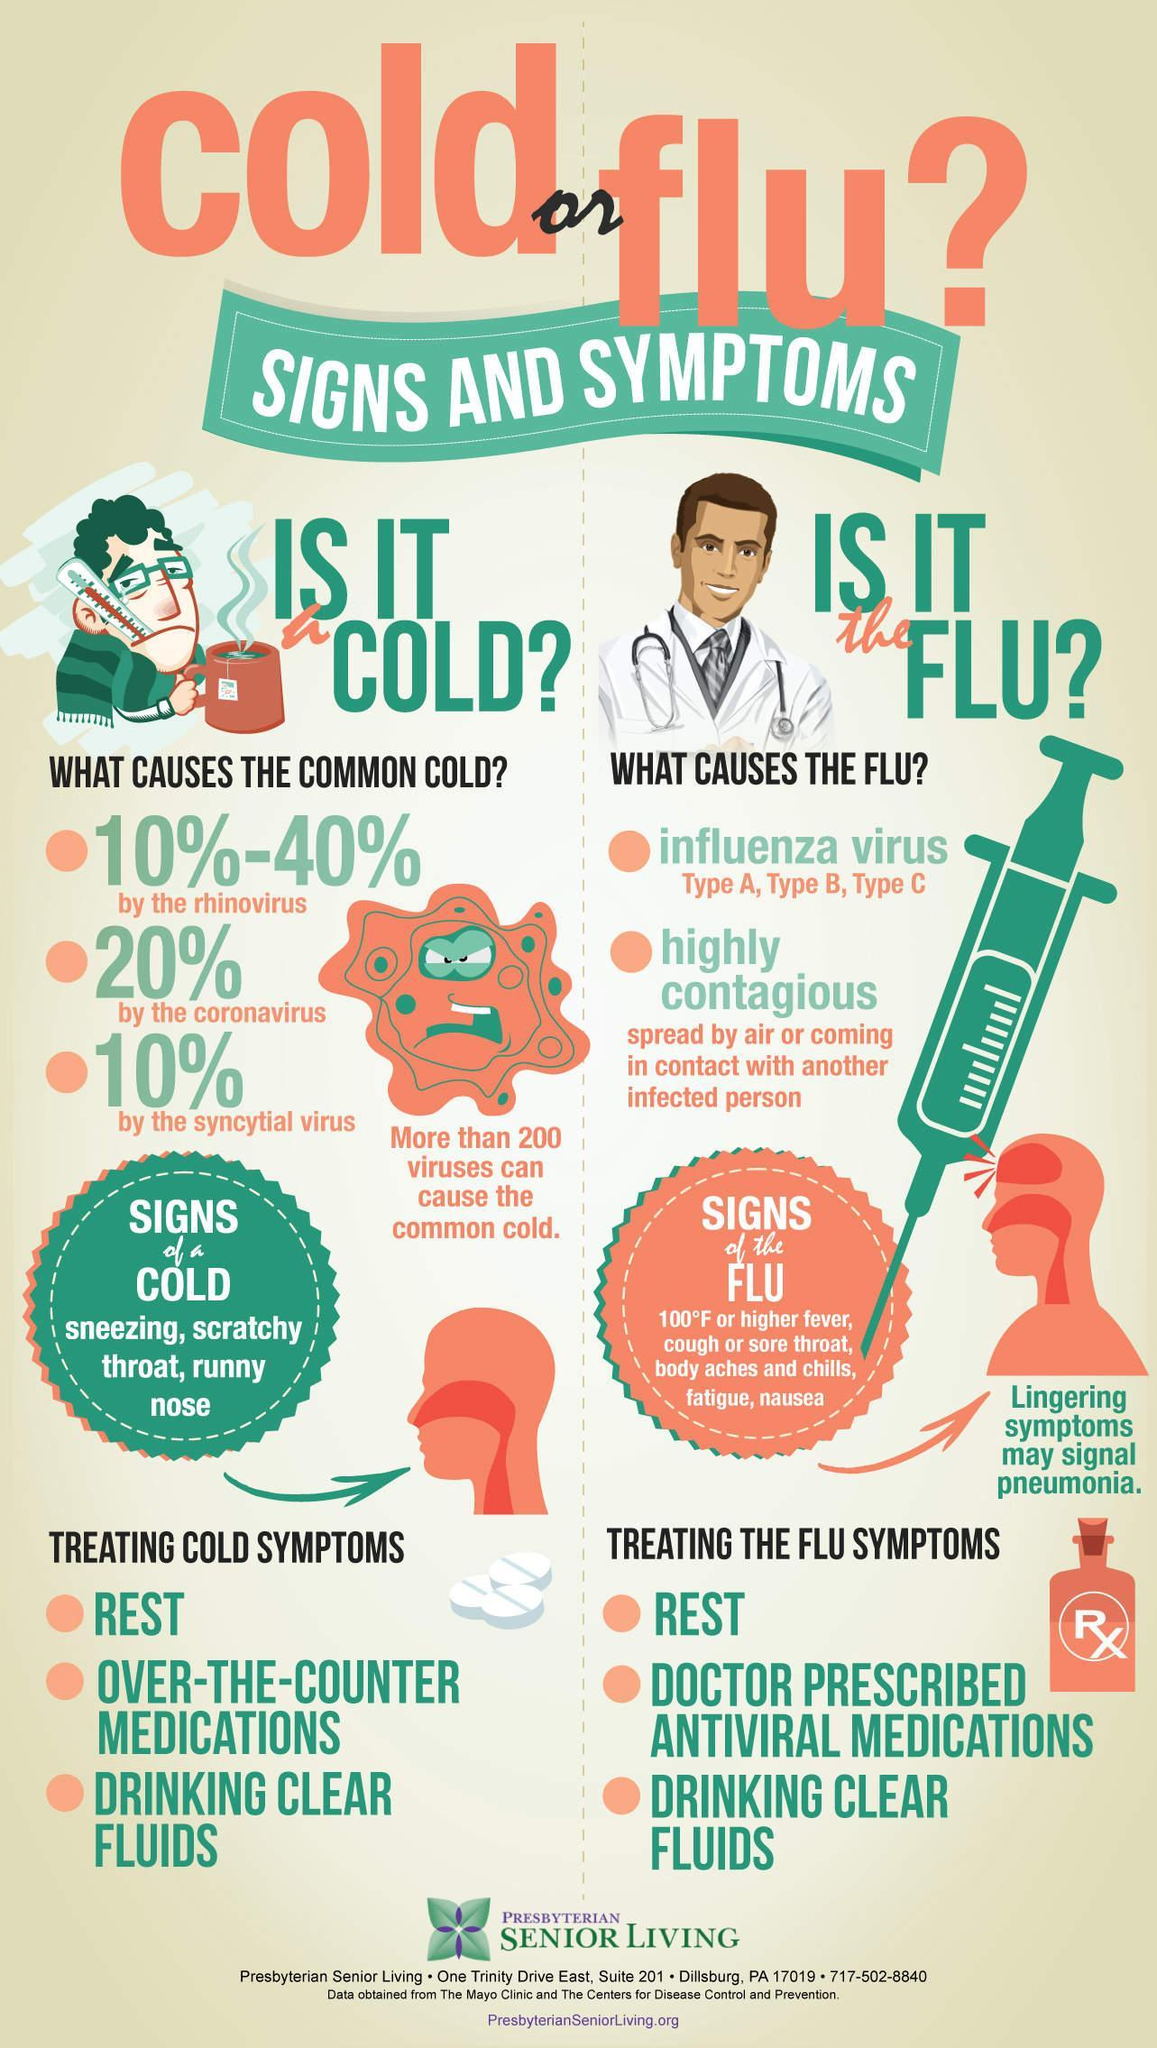What percent of the common cold is caused by the syncytial virus?
Answer the question with a short phrase. 10% Which viruses are responsible for causing common cold? rhinovirus, coronavirus, syncytial virus Which treatment methods are used for both cold & flu symptoms? REST, DRINKING CLEAR FLUIDS What percent of the common cold is caused by the  rhinovirus? 10%-40% Which type of virus causes the Flu? influenza virus What is the best medication for flu symptoms? ANTIVIRAL MEDICATIONS What are the different types of influenza virus? Type A, Type B, Type C 